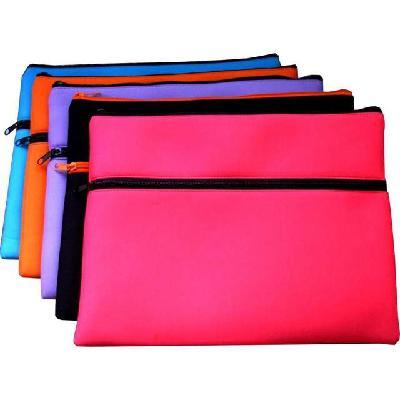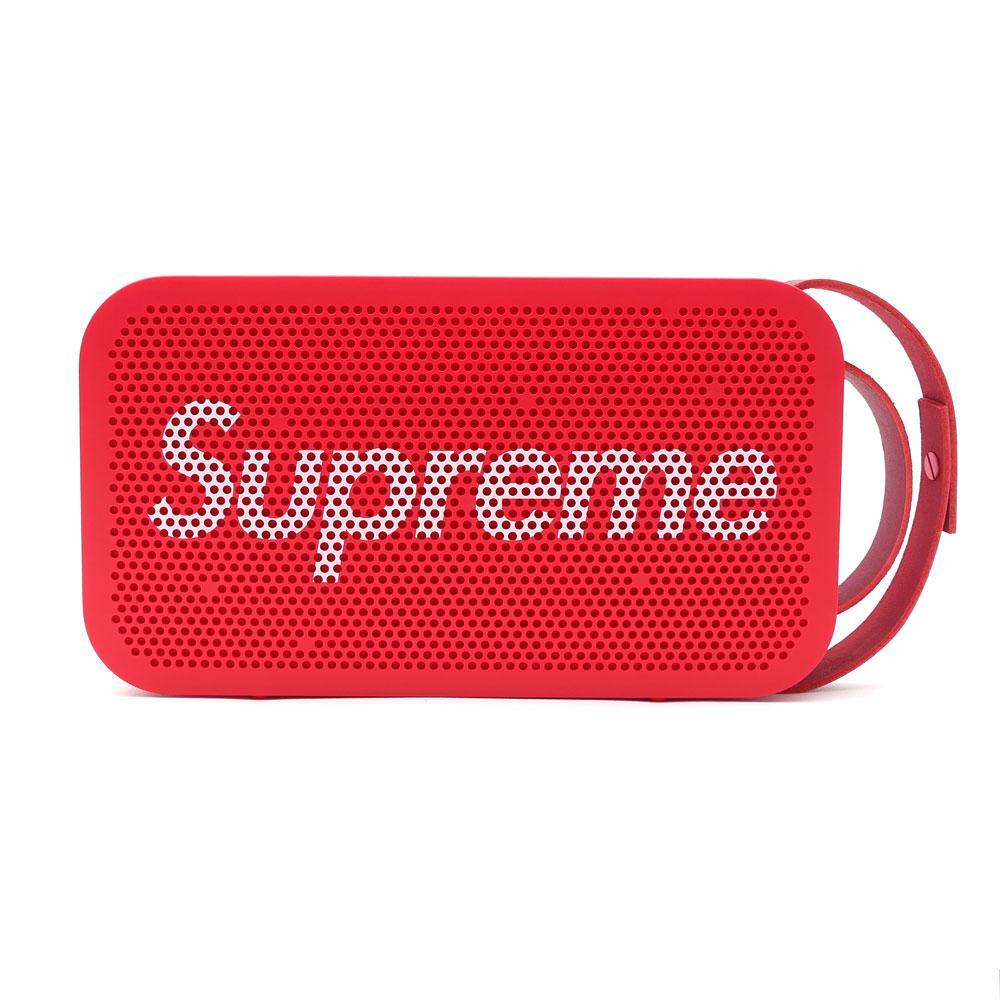The first image is the image on the left, the second image is the image on the right. Considering the images on both sides, is "The left image shows an overlapping, upright row of at least three color versions of a pencil case style." valid? Answer yes or no. Yes. The first image is the image on the left, the second image is the image on the right. Evaluate the accuracy of this statement regarding the images: "In at least one image there is a pencil case with colored stripe patterns on the side of the case.". Is it true? Answer yes or no. No. 